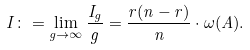<formula> <loc_0><loc_0><loc_500><loc_500>I \colon = \lim _ { g \to \infty } \frac { I _ { g } } { g } = \frac { r ( n - r ) } { n } \cdot \omega ( A ) .</formula> 